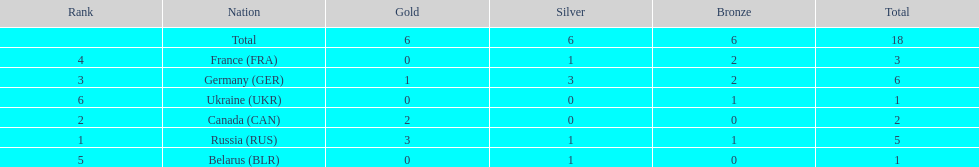What were the only 3 countries to win gold medals at the the 1994 winter olympics biathlon? Russia (RUS), Canada (CAN), Germany (GER). 